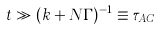Convert formula to latex. <formula><loc_0><loc_0><loc_500><loc_500>t \gg ( k + N \Gamma ) ^ { - 1 } \equiv \tau _ { A C }</formula> 